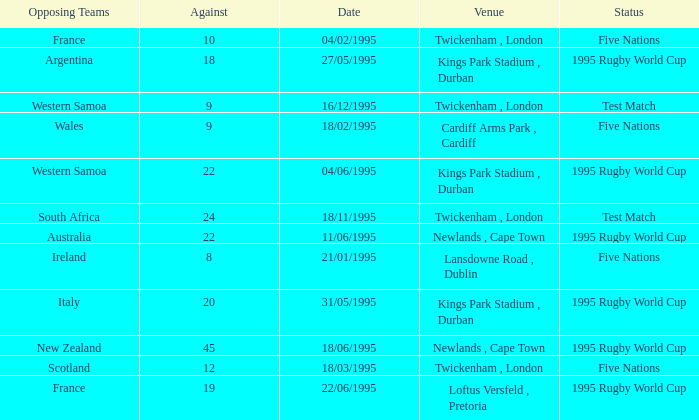Could you parse the entire table? {'header': ['Opposing Teams', 'Against', 'Date', 'Venue', 'Status'], 'rows': [['France', '10', '04/02/1995', 'Twickenham , London', 'Five Nations'], ['Argentina', '18', '27/05/1995', 'Kings Park Stadium , Durban', '1995 Rugby World Cup'], ['Western Samoa', '9', '16/12/1995', 'Twickenham , London', 'Test Match'], ['Wales', '9', '18/02/1995', 'Cardiff Arms Park , Cardiff', 'Five Nations'], ['Western Samoa', '22', '04/06/1995', 'Kings Park Stadium , Durban', '1995 Rugby World Cup'], ['South Africa', '24', '18/11/1995', 'Twickenham , London', 'Test Match'], ['Australia', '22', '11/06/1995', 'Newlands , Cape Town', '1995 Rugby World Cup'], ['Ireland', '8', '21/01/1995', 'Lansdowne Road , Dublin', 'Five Nations'], ['Italy', '20', '31/05/1995', 'Kings Park Stadium , Durban', '1995 Rugby World Cup'], ['New Zealand', '45', '18/06/1995', 'Newlands , Cape Town', '1995 Rugby World Cup'], ['Scotland', '12', '18/03/1995', 'Twickenham , London', 'Five Nations'], ['France', '19', '22/06/1995', 'Loftus Versfeld , Pretoria', '1995 Rugby World Cup']]} What's the total against for opposing team scotland at twickenham, london venue with a status of five nations? 1.0. 